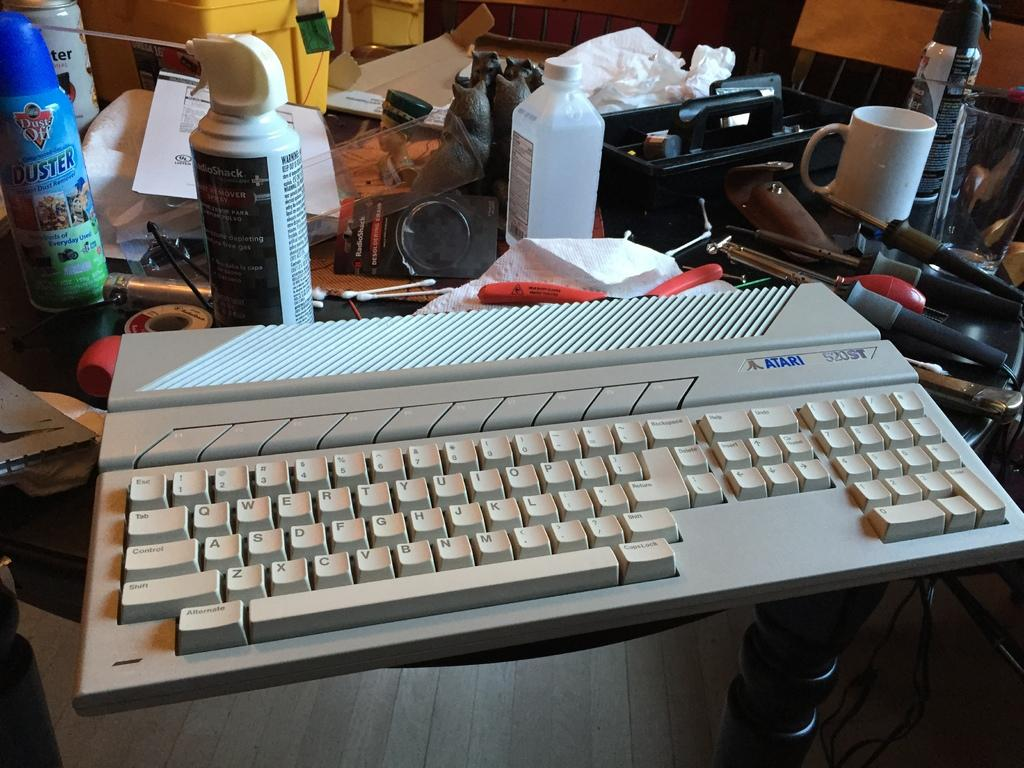Provide a one-sentence caption for the provided image. An old Atari keyboard sitting on a table cluttered with tools and sprays. 